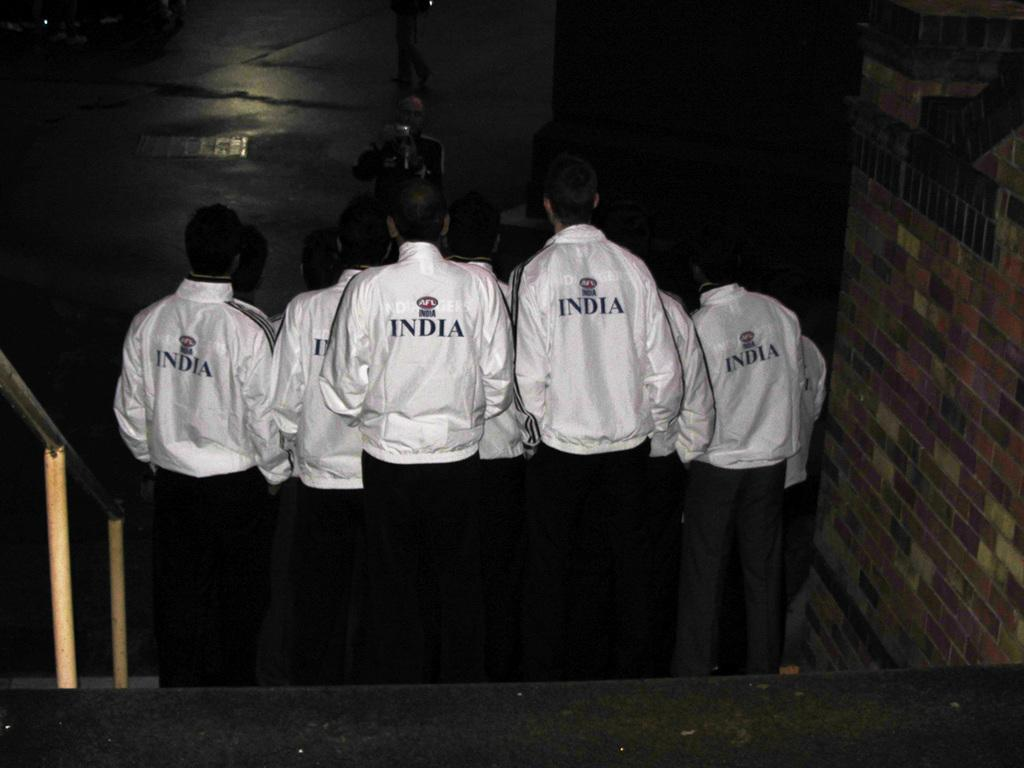<image>
Offer a succinct explanation of the picture presented. Group of people wearing sweaters that say India in a huddle. 